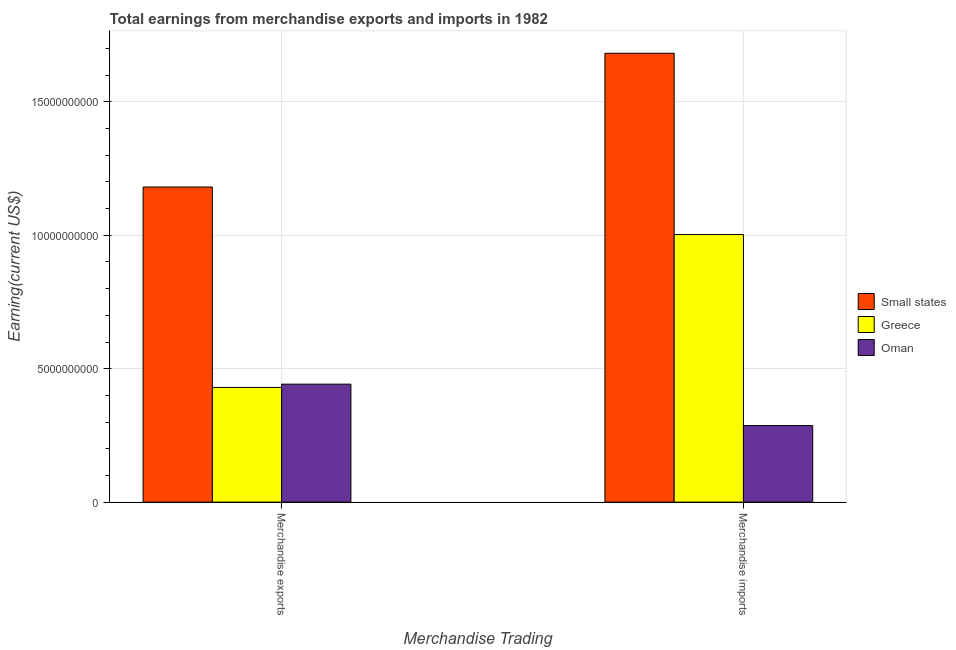Are the number of bars per tick equal to the number of legend labels?
Your response must be concise. Yes. What is the label of the 2nd group of bars from the left?
Provide a succinct answer. Merchandise imports. What is the earnings from merchandise imports in Oman?
Ensure brevity in your answer.  2.87e+09. Across all countries, what is the maximum earnings from merchandise exports?
Offer a very short reply. 1.18e+1. Across all countries, what is the minimum earnings from merchandise exports?
Make the answer very short. 4.30e+09. In which country was the earnings from merchandise imports maximum?
Offer a terse response. Small states. In which country was the earnings from merchandise imports minimum?
Your answer should be compact. Oman. What is the total earnings from merchandise imports in the graph?
Provide a succinct answer. 2.97e+1. What is the difference between the earnings from merchandise exports in Small states and that in Oman?
Ensure brevity in your answer.  7.39e+09. What is the difference between the earnings from merchandise imports in Oman and the earnings from merchandise exports in Greece?
Ensure brevity in your answer.  -1.43e+09. What is the average earnings from merchandise exports per country?
Offer a terse response. 6.84e+09. What is the difference between the earnings from merchandise exports and earnings from merchandise imports in Oman?
Your answer should be compact. 1.55e+09. In how many countries, is the earnings from merchandise imports greater than 7000000000 US$?
Offer a terse response. 2. What is the ratio of the earnings from merchandise imports in Oman to that in Greece?
Offer a terse response. 0.29. Is the earnings from merchandise imports in Oman less than that in Small states?
Ensure brevity in your answer.  Yes. In how many countries, is the earnings from merchandise imports greater than the average earnings from merchandise imports taken over all countries?
Ensure brevity in your answer.  2. What does the 3rd bar from the left in Merchandise exports represents?
Your answer should be very brief. Oman. What does the 2nd bar from the right in Merchandise exports represents?
Offer a very short reply. Greece. Are all the bars in the graph horizontal?
Your answer should be very brief. No. What is the difference between two consecutive major ticks on the Y-axis?
Offer a very short reply. 5.00e+09. Does the graph contain grids?
Keep it short and to the point. Yes. How many legend labels are there?
Provide a short and direct response. 3. What is the title of the graph?
Make the answer very short. Total earnings from merchandise exports and imports in 1982. What is the label or title of the X-axis?
Your answer should be very brief. Merchandise Trading. What is the label or title of the Y-axis?
Make the answer very short. Earning(current US$). What is the Earning(current US$) in Small states in Merchandise exports?
Offer a very short reply. 1.18e+1. What is the Earning(current US$) of Greece in Merchandise exports?
Your answer should be compact. 4.30e+09. What is the Earning(current US$) of Oman in Merchandise exports?
Keep it short and to the point. 4.42e+09. What is the Earning(current US$) in Small states in Merchandise imports?
Provide a succinct answer. 1.68e+1. What is the Earning(current US$) in Greece in Merchandise imports?
Offer a terse response. 1.00e+1. What is the Earning(current US$) in Oman in Merchandise imports?
Provide a short and direct response. 2.87e+09. Across all Merchandise Trading, what is the maximum Earning(current US$) of Small states?
Ensure brevity in your answer.  1.68e+1. Across all Merchandise Trading, what is the maximum Earning(current US$) of Greece?
Keep it short and to the point. 1.00e+1. Across all Merchandise Trading, what is the maximum Earning(current US$) of Oman?
Give a very brief answer. 4.42e+09. Across all Merchandise Trading, what is the minimum Earning(current US$) of Small states?
Make the answer very short. 1.18e+1. Across all Merchandise Trading, what is the minimum Earning(current US$) of Greece?
Ensure brevity in your answer.  4.30e+09. Across all Merchandise Trading, what is the minimum Earning(current US$) of Oman?
Give a very brief answer. 2.87e+09. What is the total Earning(current US$) of Small states in the graph?
Your answer should be very brief. 2.86e+1. What is the total Earning(current US$) of Greece in the graph?
Make the answer very short. 1.43e+1. What is the total Earning(current US$) of Oman in the graph?
Your response must be concise. 7.29e+09. What is the difference between the Earning(current US$) in Small states in Merchandise exports and that in Merchandise imports?
Keep it short and to the point. -5.01e+09. What is the difference between the Earning(current US$) in Greece in Merchandise exports and that in Merchandise imports?
Offer a terse response. -5.73e+09. What is the difference between the Earning(current US$) in Oman in Merchandise exports and that in Merchandise imports?
Offer a terse response. 1.55e+09. What is the difference between the Earning(current US$) in Small states in Merchandise exports and the Earning(current US$) in Greece in Merchandise imports?
Offer a terse response. 1.78e+09. What is the difference between the Earning(current US$) in Small states in Merchandise exports and the Earning(current US$) in Oman in Merchandise imports?
Ensure brevity in your answer.  8.94e+09. What is the difference between the Earning(current US$) in Greece in Merchandise exports and the Earning(current US$) in Oman in Merchandise imports?
Keep it short and to the point. 1.43e+09. What is the average Earning(current US$) in Small states per Merchandise Trading?
Offer a very short reply. 1.43e+1. What is the average Earning(current US$) in Greece per Merchandise Trading?
Make the answer very short. 7.16e+09. What is the average Earning(current US$) in Oman per Merchandise Trading?
Keep it short and to the point. 3.64e+09. What is the difference between the Earning(current US$) of Small states and Earning(current US$) of Greece in Merchandise exports?
Offer a terse response. 7.51e+09. What is the difference between the Earning(current US$) in Small states and Earning(current US$) in Oman in Merchandise exports?
Offer a terse response. 7.39e+09. What is the difference between the Earning(current US$) in Greece and Earning(current US$) in Oman in Merchandise exports?
Ensure brevity in your answer.  -1.23e+08. What is the difference between the Earning(current US$) in Small states and Earning(current US$) in Greece in Merchandise imports?
Your answer should be compact. 6.79e+09. What is the difference between the Earning(current US$) of Small states and Earning(current US$) of Oman in Merchandise imports?
Give a very brief answer. 1.40e+1. What is the difference between the Earning(current US$) in Greece and Earning(current US$) in Oman in Merchandise imports?
Give a very brief answer. 7.16e+09. What is the ratio of the Earning(current US$) in Small states in Merchandise exports to that in Merchandise imports?
Give a very brief answer. 0.7. What is the ratio of the Earning(current US$) in Greece in Merchandise exports to that in Merchandise imports?
Ensure brevity in your answer.  0.43. What is the ratio of the Earning(current US$) in Oman in Merchandise exports to that in Merchandise imports?
Your answer should be very brief. 1.54. What is the difference between the highest and the second highest Earning(current US$) in Small states?
Provide a short and direct response. 5.01e+09. What is the difference between the highest and the second highest Earning(current US$) of Greece?
Give a very brief answer. 5.73e+09. What is the difference between the highest and the second highest Earning(current US$) of Oman?
Offer a terse response. 1.55e+09. What is the difference between the highest and the lowest Earning(current US$) of Small states?
Your answer should be compact. 5.01e+09. What is the difference between the highest and the lowest Earning(current US$) of Greece?
Your answer should be compact. 5.73e+09. What is the difference between the highest and the lowest Earning(current US$) of Oman?
Keep it short and to the point. 1.55e+09. 